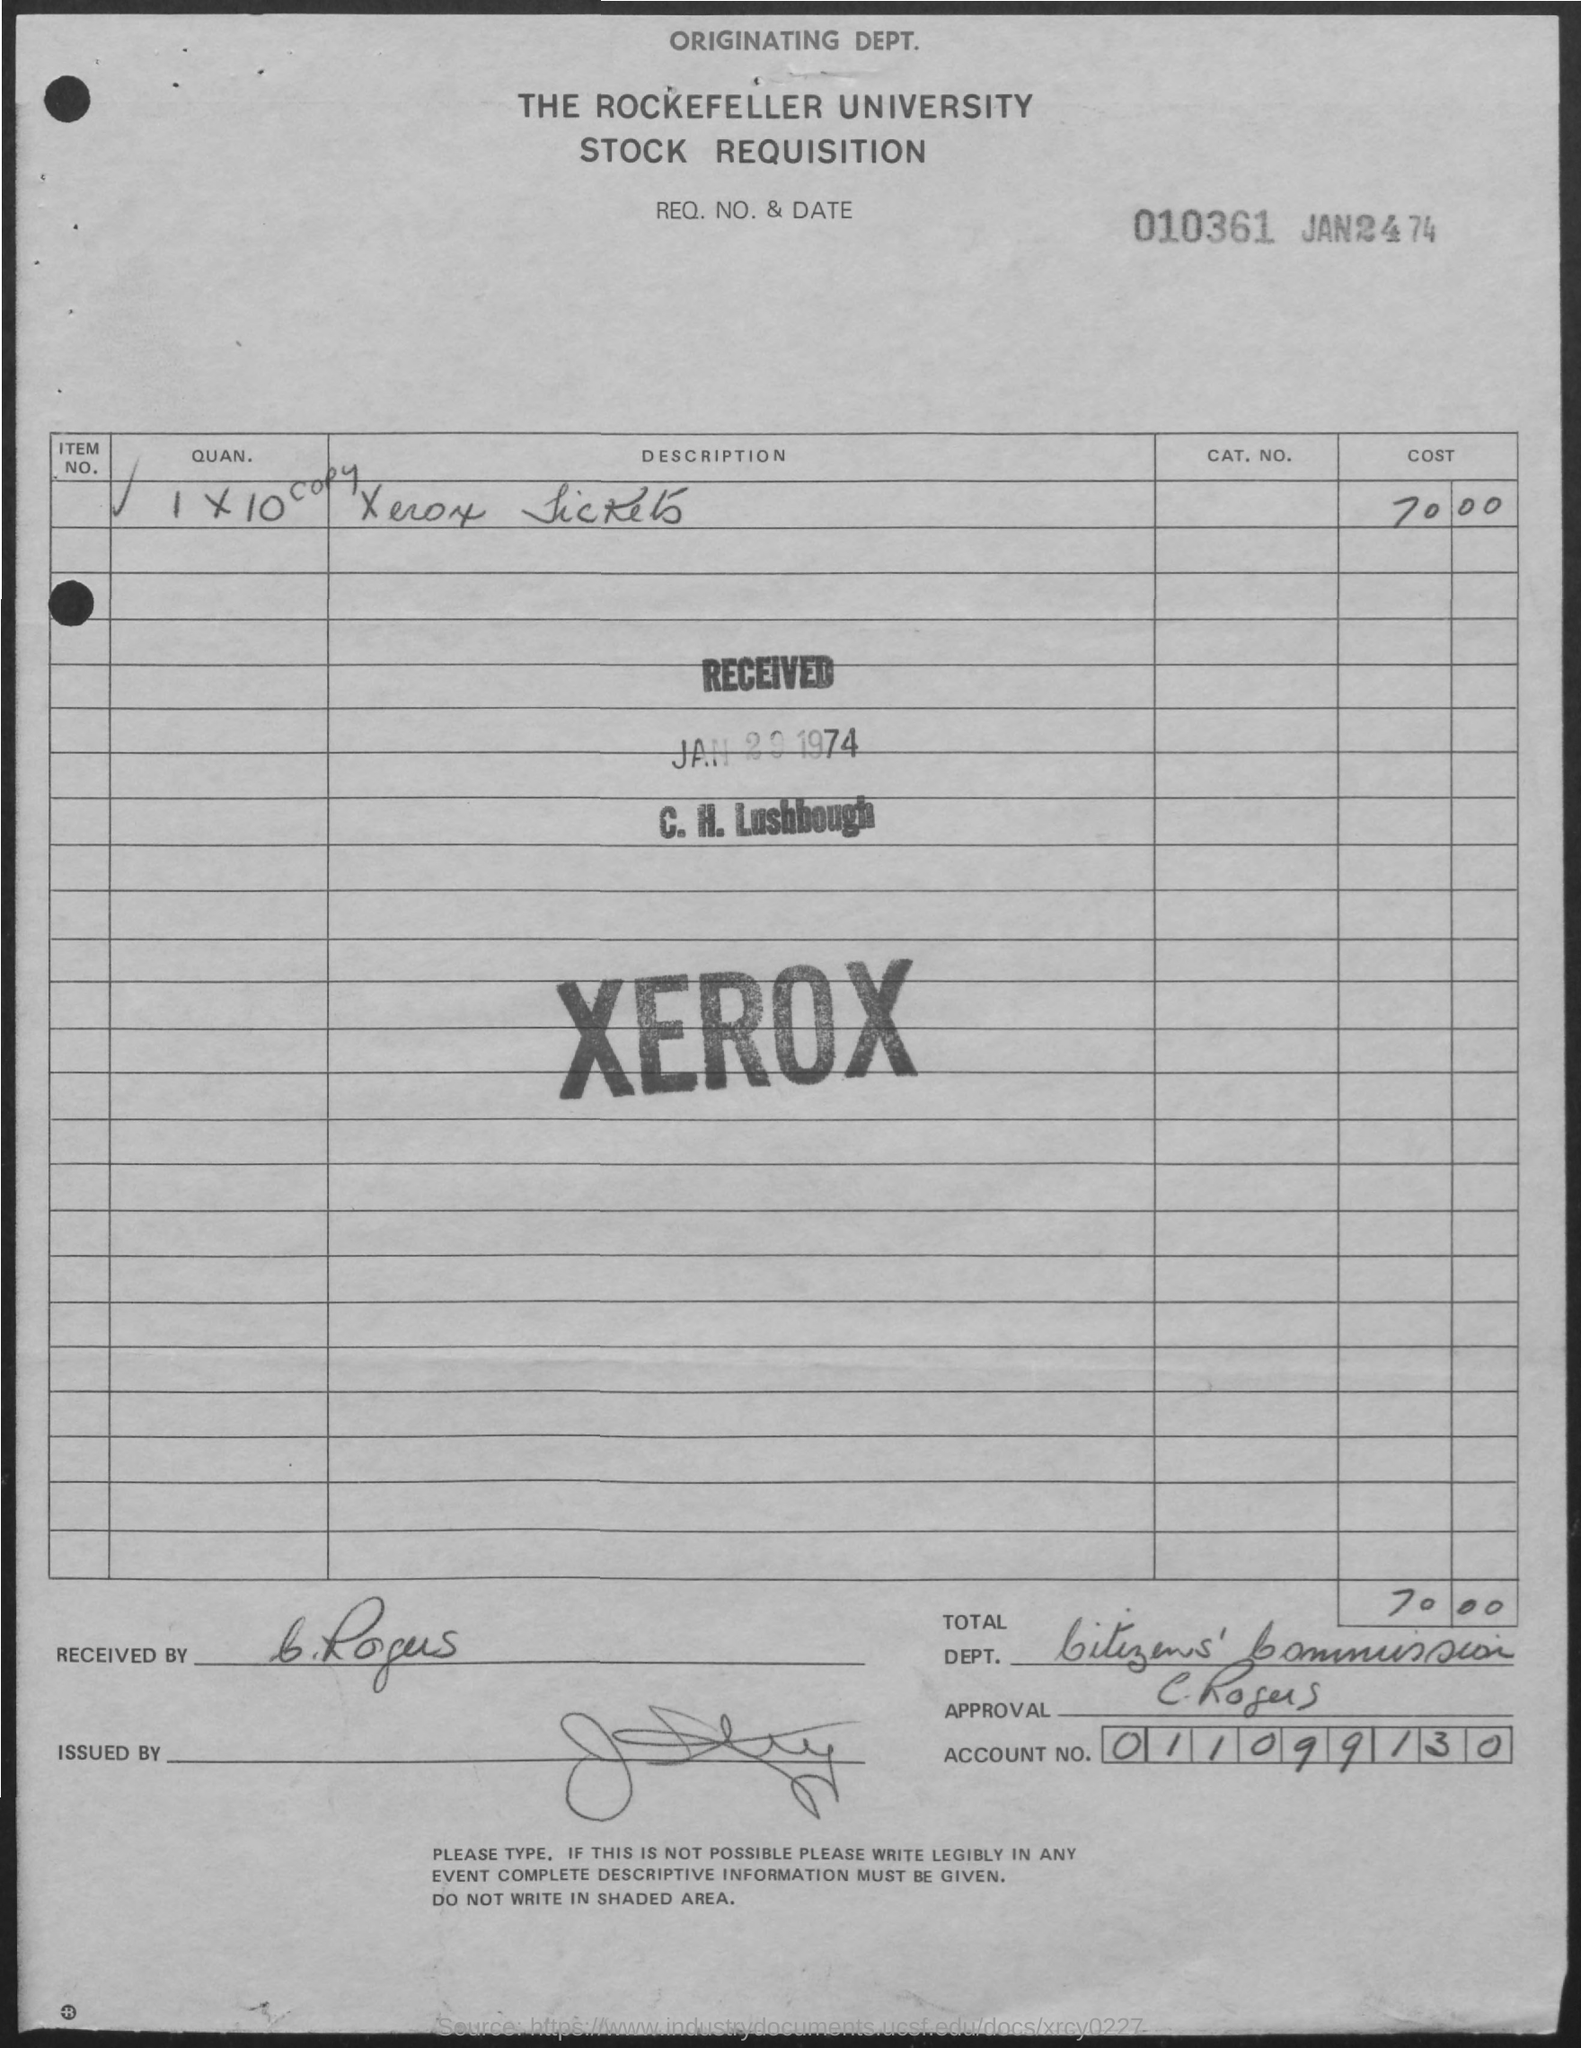What is the date of document?
Your answer should be very brief. JAN24 74. What is req no.?
Provide a succinct answer. 010361. What is account number mentioned?
Make the answer very short. 011099130. What is the cost of xerox?
Keep it short and to the point. 70.00. 